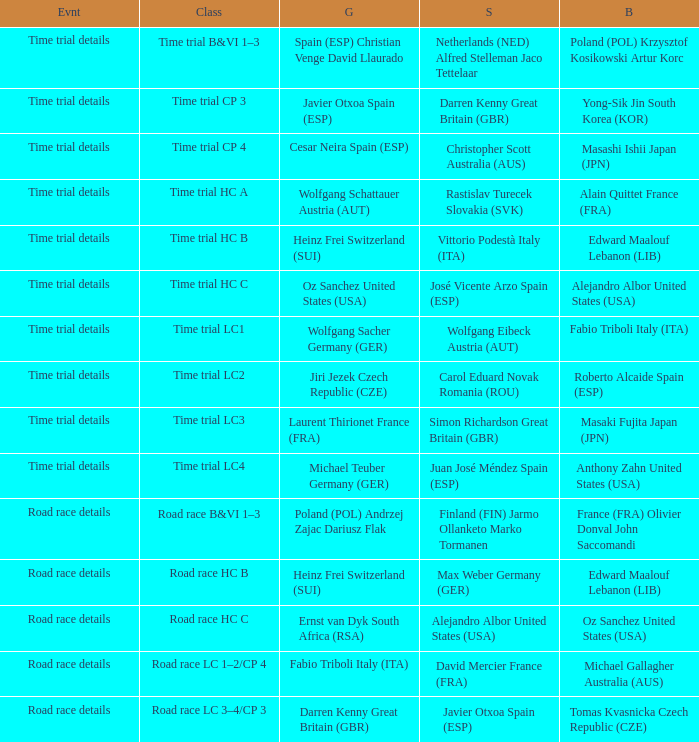What is the event when the class is time trial hc a? Time trial details. 